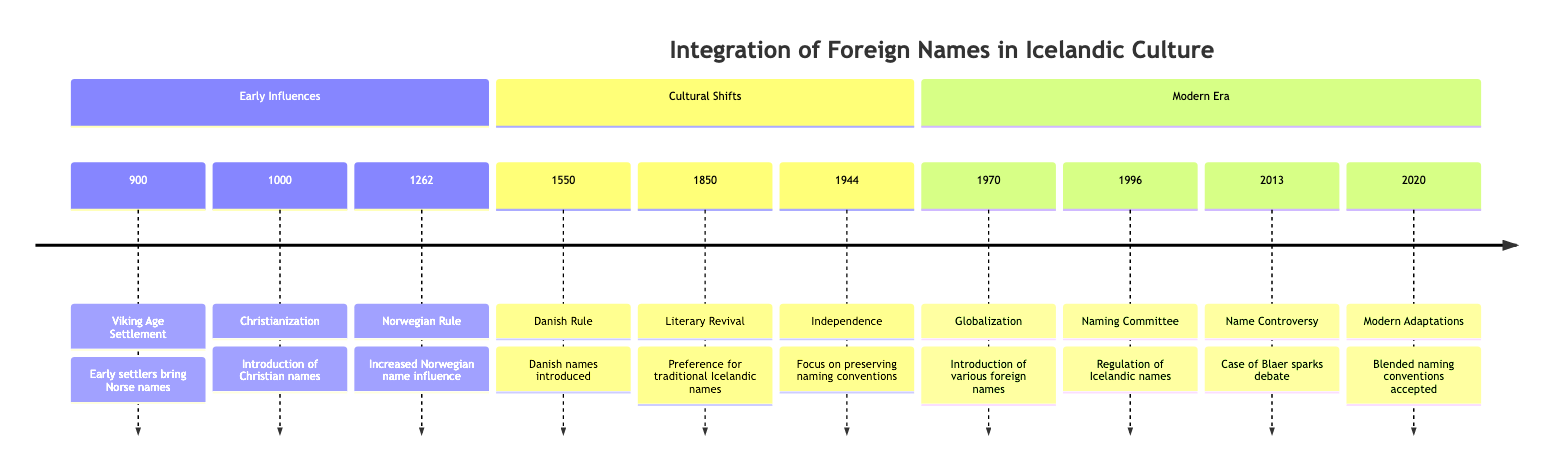What year did the Viking Age Settlement occur? The timeline indicates that the Viking Age Settlement event is placed at the year 900. The event title is explicitly stated alongside its corresponding year.
Answer: 900 Which event introduced Christian names in Iceland? According to the timeline, the event labeled "Christianization of Iceland" in the year 1000 indicates that this was the point when Christian names were introduced. The event title directly correlates with the introduction of Christian names.
Answer: Christianization of Iceland What influence was noted during the integration into the Norwegian Kingdom? From the details provided in the timeline, the year 1262 highlights that there was increased influence of Norwegian names as Iceland fell under Norwegian rule. Thus, the Norwegian influence is the key point in this context.
Answer: Increased Norwegian names How many major cultural shifts are mentioned in the timeline? By examining the timeline, the section labeled "Cultural Shifts" features three distinct events: Danish Rule, Literary Revival, and Independence. This allows us to conclude that there are three major shifts referenced.
Answer: 3 Which event marks the beginning of modern adaptations to naming conventions? The timeline specifies the year 2020 with the event "Modern Adaptations," suggesting that this is where the process of accepting blended naming conventions began. The event title directly indicates it is a modern adaptation.
Answer: Modern Adaptations What was established in 1996 concerning Icelandic names? The timeline details that in 1996, the "Icelandic Naming Committee" was established. This highlights a regulatory measure over Icelandic names. The wording plainly shows the establishment's purpose regarding names.
Answer: Icelandic Naming Committee What year experienced an increase in globalization affecting Icelandic names? The timeline indicates the year 1970 as the period when increased globalization introduced various foreign names to Iceland. This information is explicitly stated, linking the year to the effect of globalization.
Answer: 1970 What legal case in 2013 sparked discussion about naming traditions? The timeline refers to the "Controversy over Name Registration" involving a girl named Blaer in the year 2013. The event title clearly indicates the specific legal case that incited the discussions regarding naming traditions.
Answer: Blaer How did the event in 1850 impact naming preferences in Iceland? The timeline notes that in 1850, during the "Literary Revival" event, there was a renewed interest leading to a preference for traditional Icelandic names over foreign ones. This suggests a significant shift in naming preferences relevant to Icelandic heritage.
Answer: Preference for traditional Icelandic names 